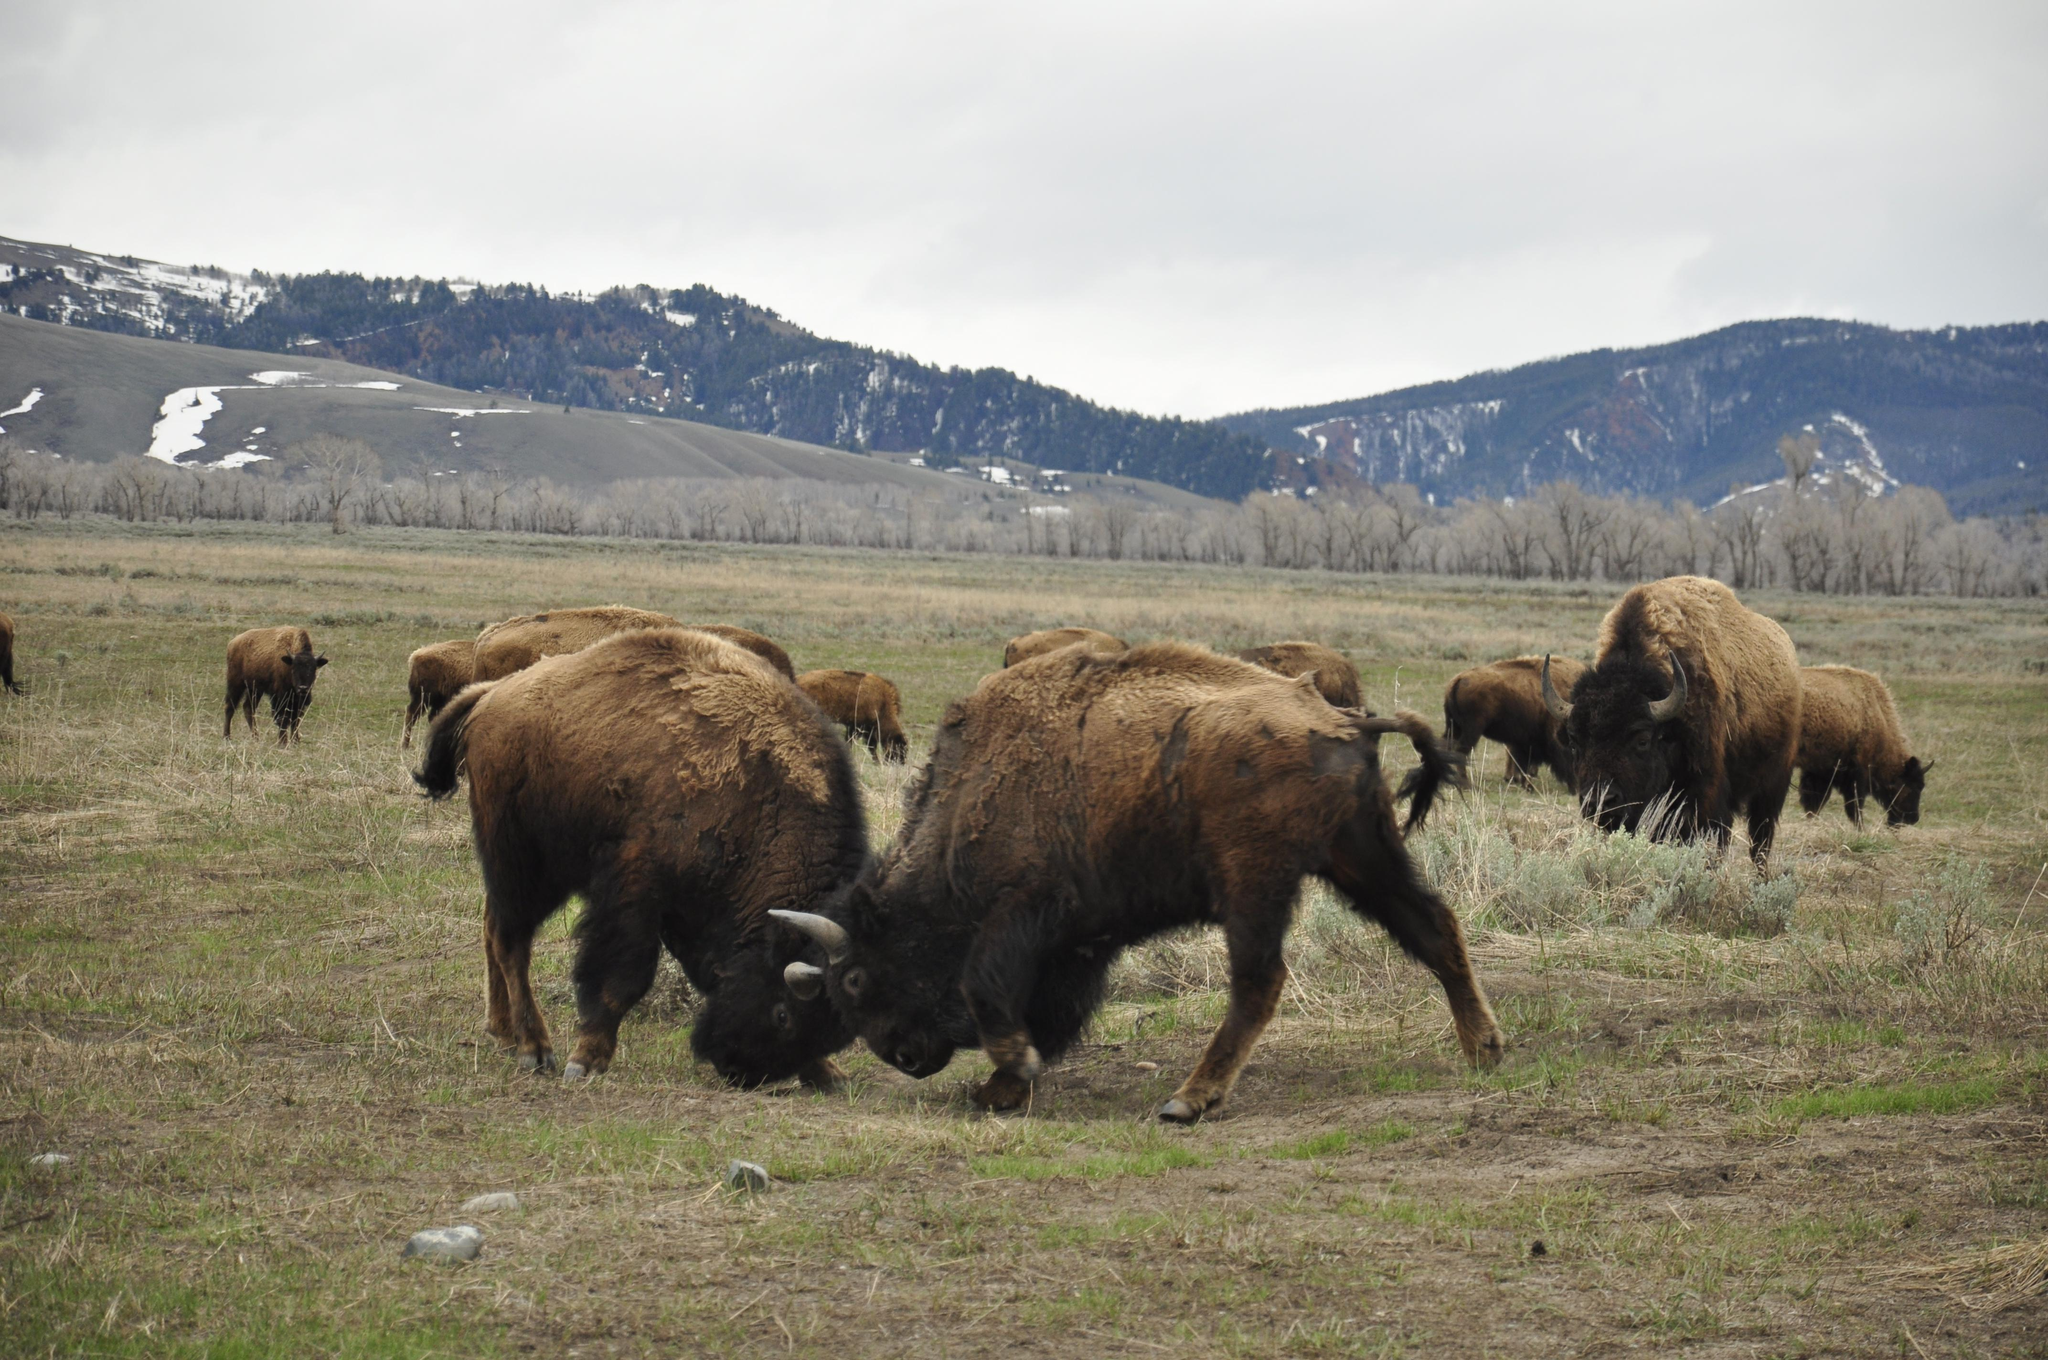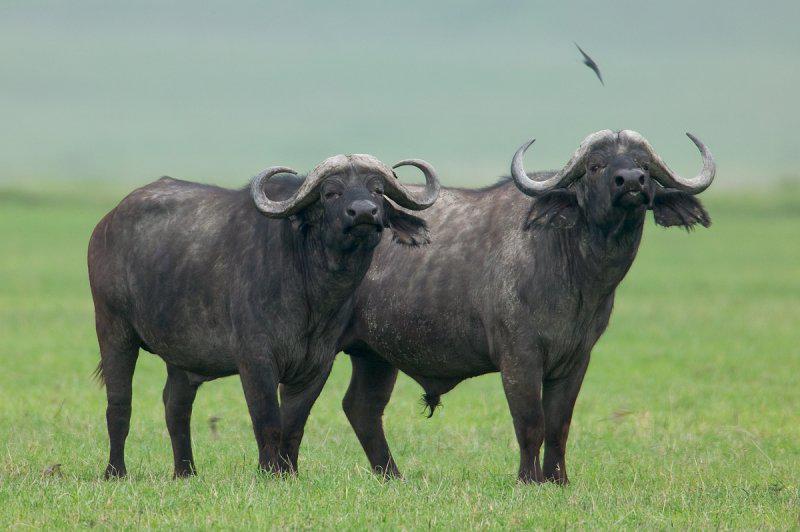The first image is the image on the left, the second image is the image on the right. For the images shown, is this caption "An area of water is present in one image of water buffalo." true? Answer yes or no. No. 